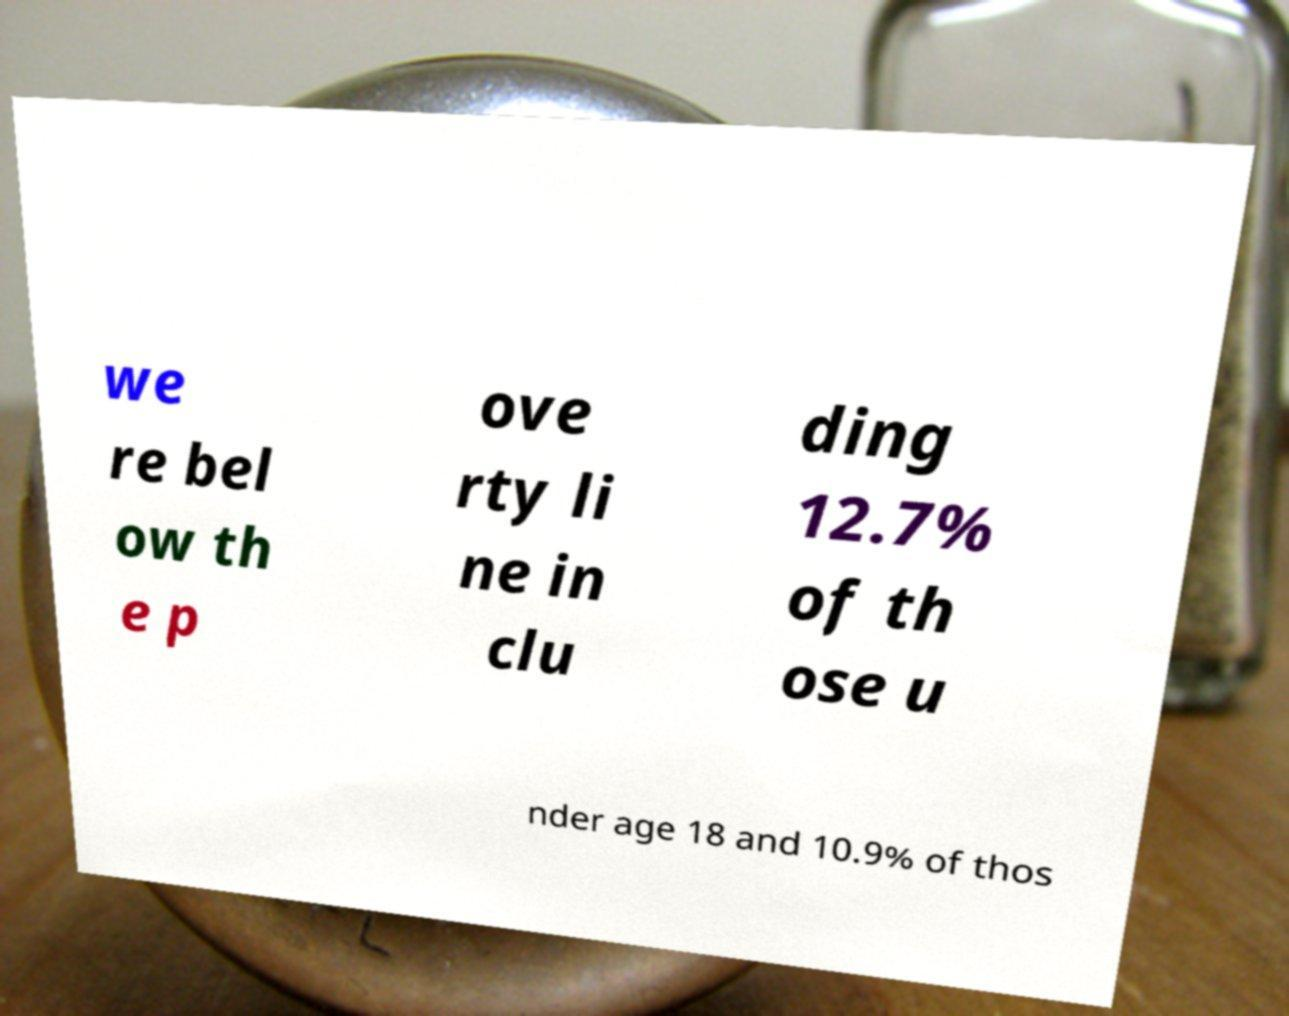Please read and relay the text visible in this image. What does it say? we re bel ow th e p ove rty li ne in clu ding 12.7% of th ose u nder age 18 and 10.9% of thos 